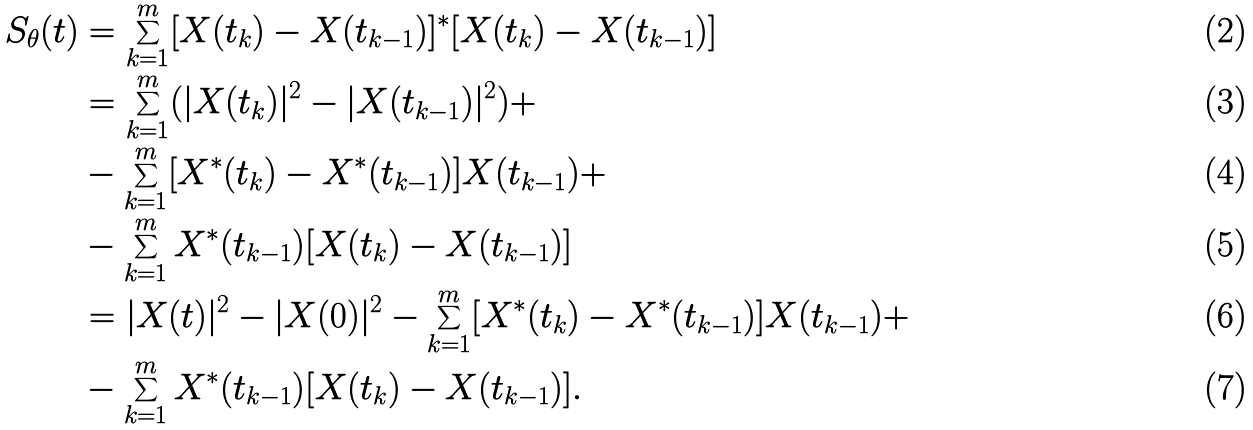Convert formula to latex. <formula><loc_0><loc_0><loc_500><loc_500>S _ { \theta } ( t ) & = \sum _ { k = 1 } ^ { m } [ X ( t _ { k } ) - X ( t _ { k - 1 } ) ] ^ { * } [ X ( t _ { k } ) - X ( t _ { k - 1 } ) ] \\ & = \sum _ { k = 1 } ^ { m } ( | X ( t _ { k } ) | ^ { 2 } - | X ( t _ { k - 1 } ) | ^ { 2 } ) + \\ & - \sum _ { k = 1 } ^ { m } [ X ^ { * } ( t _ { k } ) - X ^ { * } ( t _ { k - 1 } ) ] X ( t _ { k - 1 } ) + \\ & - \sum _ { k = 1 } ^ { m } X ^ { * } ( t _ { k - 1 } ) [ X ( t _ { k } ) - X ( t _ { k - 1 } ) ] \\ & = | X ( t ) | ^ { 2 } - | X ( 0 ) | ^ { 2 } - \sum _ { k = 1 } ^ { m } [ X ^ { * } ( t _ { k } ) - X ^ { * } ( t _ { k - 1 } ) ] X ( t _ { k - 1 } ) + \\ & - \sum _ { k = 1 } ^ { m } X ^ { * } ( t _ { k - 1 } ) [ X ( t _ { k } ) - X ( t _ { k - 1 } ) ] .</formula> 